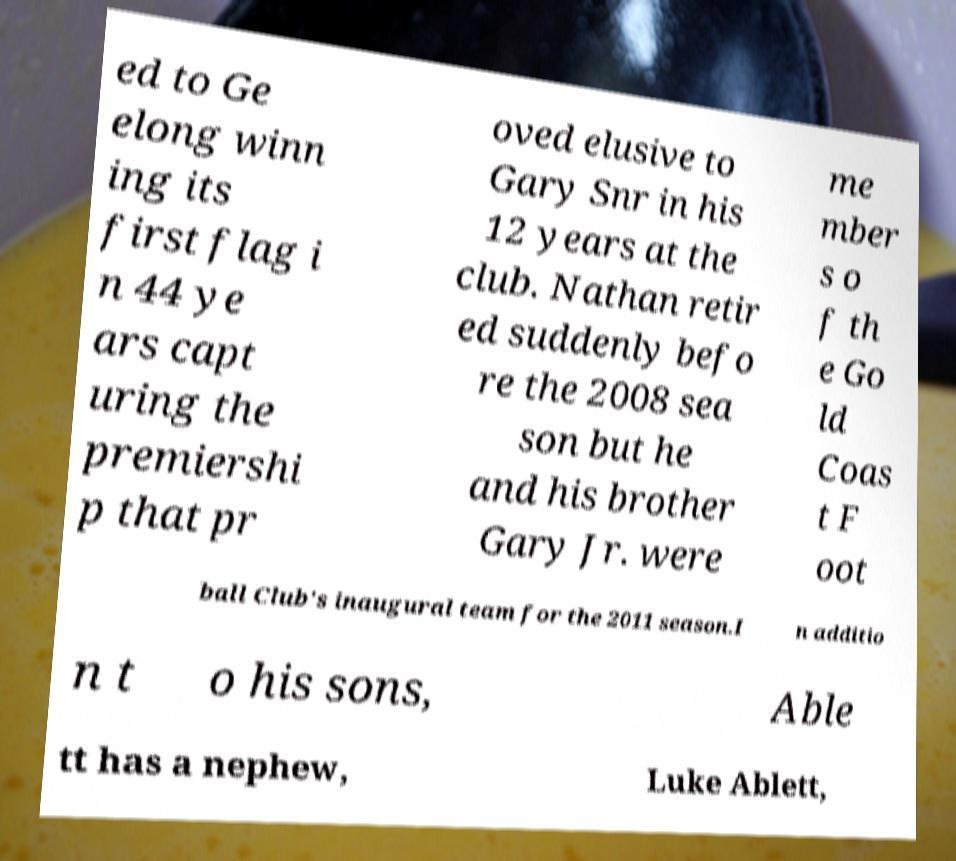Could you assist in decoding the text presented in this image and type it out clearly? ed to Ge elong winn ing its first flag i n 44 ye ars capt uring the premiershi p that pr oved elusive to Gary Snr in his 12 years at the club. Nathan retir ed suddenly befo re the 2008 sea son but he and his brother Gary Jr. were me mber s o f th e Go ld Coas t F oot ball Club's inaugural team for the 2011 season.I n additio n t o his sons, Able tt has a nephew, Luke Ablett, 